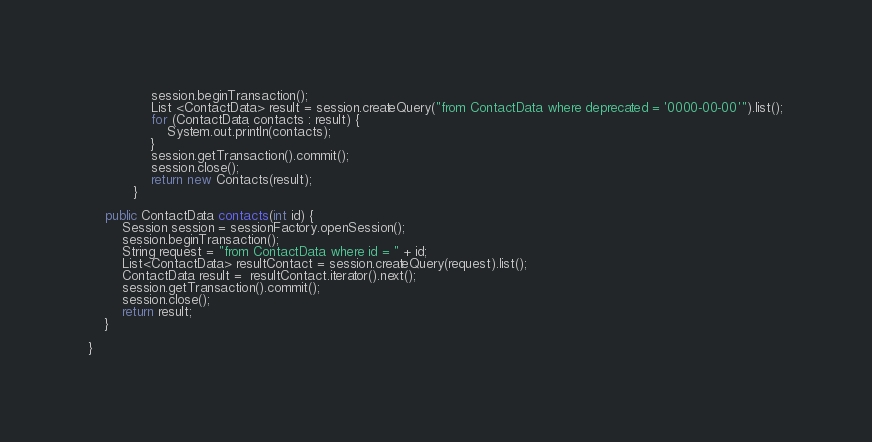Convert code to text. <code><loc_0><loc_0><loc_500><loc_500><_Java_>               session.beginTransaction();
               List <ContactData> result = session.createQuery("from ContactData where deprecated = '0000-00-00'").list();
               for (ContactData contacts : result) {
                   System.out.println(contacts);
               }
               session.getTransaction().commit();
               session.close();
               return new Contacts(result);
           }

    public ContactData contacts(int id) {
        Session session = sessionFactory.openSession();
        session.beginTransaction();
        String request = "from ContactData where id = " + id;
        List<ContactData> resultContact = session.createQuery(request).list();
        ContactData result =  resultContact.iterator().next();
        session.getTransaction().commit();
        session.close();
        return result;
    }

}
</code> 